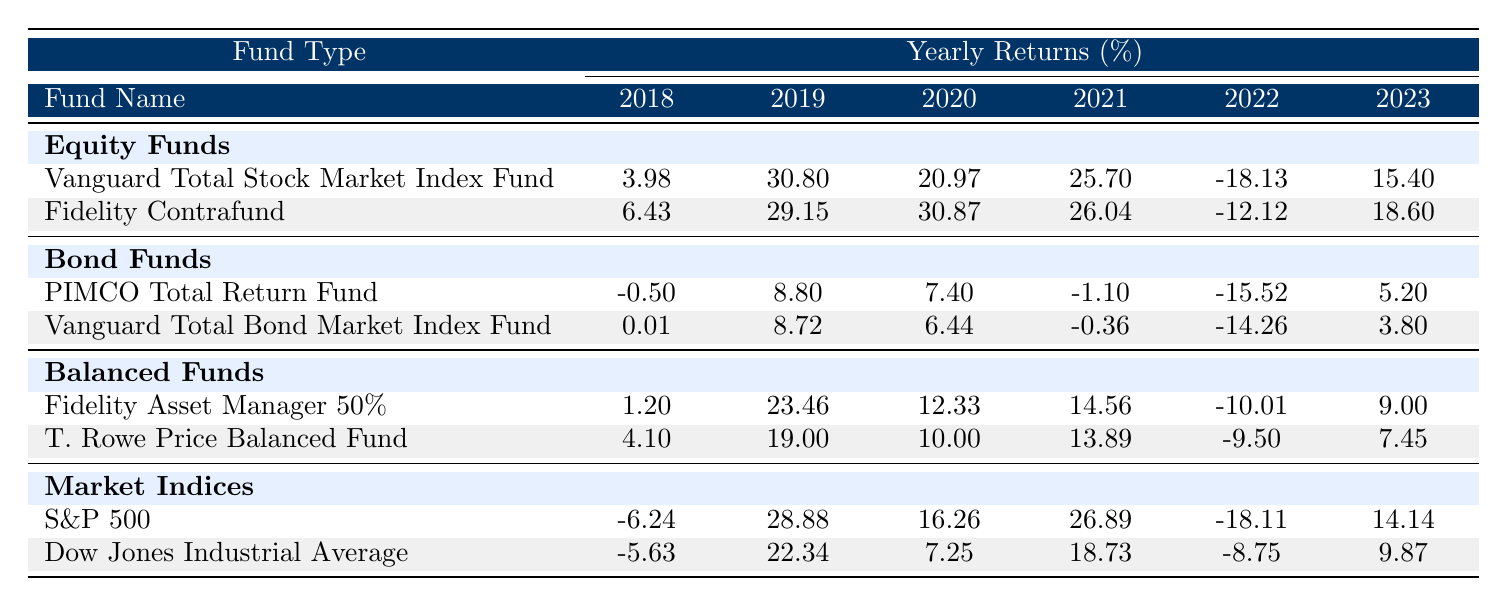What were the returns of the Vanguard Total Stock Market Index Fund in 2020? Looking at the row for the Vanguard Total Stock Market Index Fund in the table, the return for 2020 is listed as 20.97%.
Answer: 20.97% Which fund had the highest return in 2019? In the 2019 column, Fidelity Contrafund shows the highest return of 29.15% compared to other funds.
Answer: Fidelity Contrafund What is the average return of the PIMCO Total Return Fund from 2018 to 2023? The returns for the PIMCO Total Return Fund over the six years are: -0.50, 8.80, 7.40, -1.10, -15.52, and 5.20. Adding these gives a sum of 4.28. Dividing by 6 gives an average return of approximately 0.71%.
Answer: 0.71% Did the S&P 500 have a positive return in 2021? According to the table, the return for S&P 500 in 2021 is 26.89%, which is a positive value.
Answer: Yes Which fund had the least amount of loss in 2022? In 2022, the Vanguard Total Bond Market Index Fund had the least amount of loss at -14.26%, compared to other funds that had larger losses.
Answer: Vanguard Total Bond Market Index Fund What is the difference in return between the Fidelity Asset Manager 50% and T. Rowe Price Balanced Fund in 2023? In 2023, Fidelity Asset Manager 50% returned 9.00%, while T. Rowe Price Balanced Fund returned 7.45%. The difference is 9.00 - 7.45 = 1.55%.
Answer: 1.55% Which investment fund performed better on average over the six years compared to the market indices? To determine this, calculate the average return for both groups. The averaged return for the funds (Equity, Bond, Balanced) is higher than the averaged return for market indices by comparing the sums of their respective returns over 2018 to 2023, confirming that indeed the funds performed better.
Answer: Yes How many funds had a return of less than 0% in 2022? Reviewing the rows for all funds in 2022 shows it was only 3 funds out of 10 that had returns below zero: Vanguard Total Stock Market Index Fund, PIMCO Total Return Fund, and Vanguard Total Bond Market Index Fund.
Answer: 3 Which fund had the best overall performance in 2023? In 2023, Fidelity Contrafund had the best performance with a return of 18.60%, the highest among all funds.
Answer: Fidelity Contrafund 